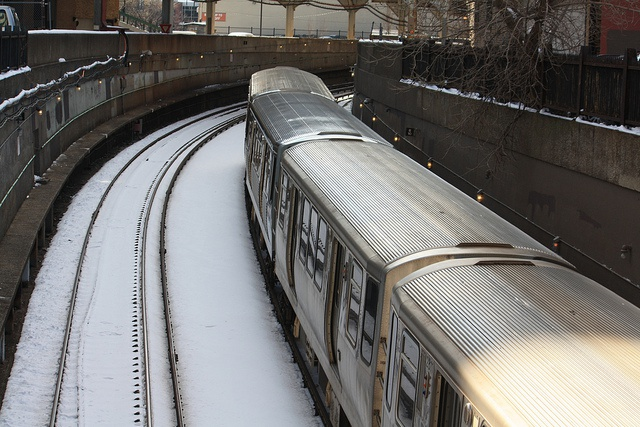Describe the objects in this image and their specific colors. I can see train in black, gray, ivory, and darkgray tones and train in black and gray tones in this image. 